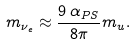Convert formula to latex. <formula><loc_0><loc_0><loc_500><loc_500>m _ { \nu _ { e } } \approx { \frac { 9 \, \alpha _ { P S } } { 8 \pi } } m _ { u } .</formula> 